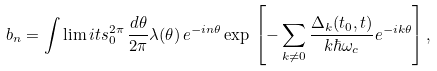<formula> <loc_0><loc_0><loc_500><loc_500>b _ { n } = \int \lim i t s _ { 0 } ^ { 2 \pi } \, \frac { d \theta } { 2 \pi } \lambda ( \theta ) \, e ^ { - i n \theta } \exp \, \left [ - \sum _ { k \neq 0 } \frac { \Delta _ { k } ( t _ { 0 } , t ) } { k \hbar { \omega } _ { c } } e ^ { - i k \theta } \right ] ,</formula> 